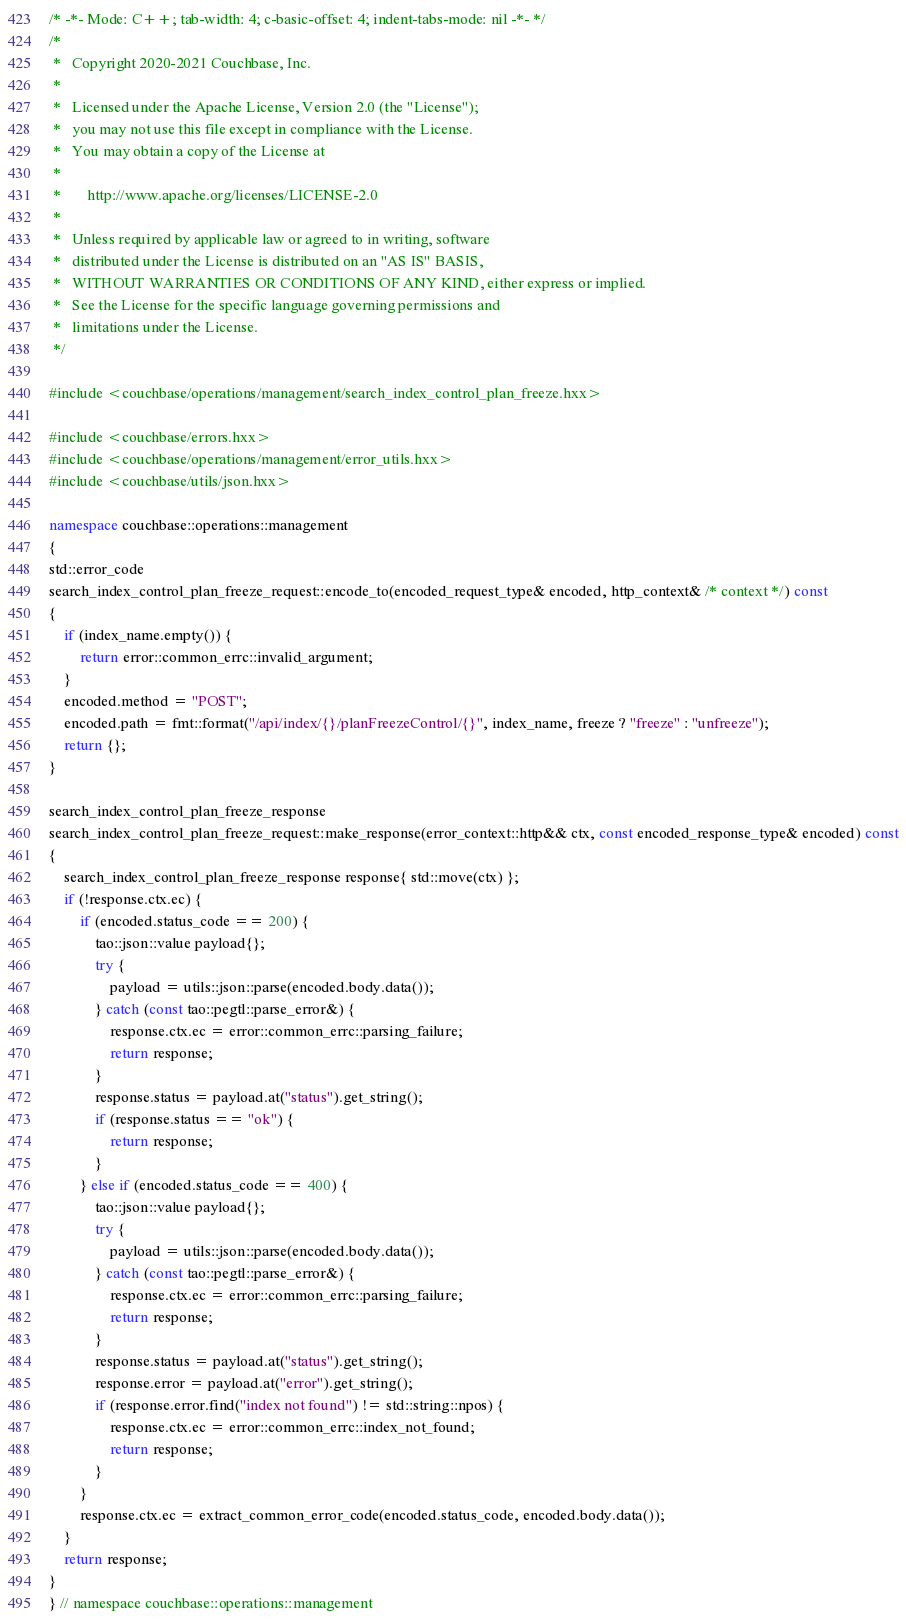<code> <loc_0><loc_0><loc_500><loc_500><_C++_>/* -*- Mode: C++; tab-width: 4; c-basic-offset: 4; indent-tabs-mode: nil -*- */
/*
 *   Copyright 2020-2021 Couchbase, Inc.
 *
 *   Licensed under the Apache License, Version 2.0 (the "License");
 *   you may not use this file except in compliance with the License.
 *   You may obtain a copy of the License at
 *
 *       http://www.apache.org/licenses/LICENSE-2.0
 *
 *   Unless required by applicable law or agreed to in writing, software
 *   distributed under the License is distributed on an "AS IS" BASIS,
 *   WITHOUT WARRANTIES OR CONDITIONS OF ANY KIND, either express or implied.
 *   See the License for the specific language governing permissions and
 *   limitations under the License.
 */

#include <couchbase/operations/management/search_index_control_plan_freeze.hxx>

#include <couchbase/errors.hxx>
#include <couchbase/operations/management/error_utils.hxx>
#include <couchbase/utils/json.hxx>

namespace couchbase::operations::management
{
std::error_code
search_index_control_plan_freeze_request::encode_to(encoded_request_type& encoded, http_context& /* context */) const
{
    if (index_name.empty()) {
        return error::common_errc::invalid_argument;
    }
    encoded.method = "POST";
    encoded.path = fmt::format("/api/index/{}/planFreezeControl/{}", index_name, freeze ? "freeze" : "unfreeze");
    return {};
}

search_index_control_plan_freeze_response
search_index_control_plan_freeze_request::make_response(error_context::http&& ctx, const encoded_response_type& encoded) const
{
    search_index_control_plan_freeze_response response{ std::move(ctx) };
    if (!response.ctx.ec) {
        if (encoded.status_code == 200) {
            tao::json::value payload{};
            try {
                payload = utils::json::parse(encoded.body.data());
            } catch (const tao::pegtl::parse_error&) {
                response.ctx.ec = error::common_errc::parsing_failure;
                return response;
            }
            response.status = payload.at("status").get_string();
            if (response.status == "ok") {
                return response;
            }
        } else if (encoded.status_code == 400) {
            tao::json::value payload{};
            try {
                payload = utils::json::parse(encoded.body.data());
            } catch (const tao::pegtl::parse_error&) {
                response.ctx.ec = error::common_errc::parsing_failure;
                return response;
            }
            response.status = payload.at("status").get_string();
            response.error = payload.at("error").get_string();
            if (response.error.find("index not found") != std::string::npos) {
                response.ctx.ec = error::common_errc::index_not_found;
                return response;
            }
        }
        response.ctx.ec = extract_common_error_code(encoded.status_code, encoded.body.data());
    }
    return response;
}
} // namespace couchbase::operations::management
</code> 